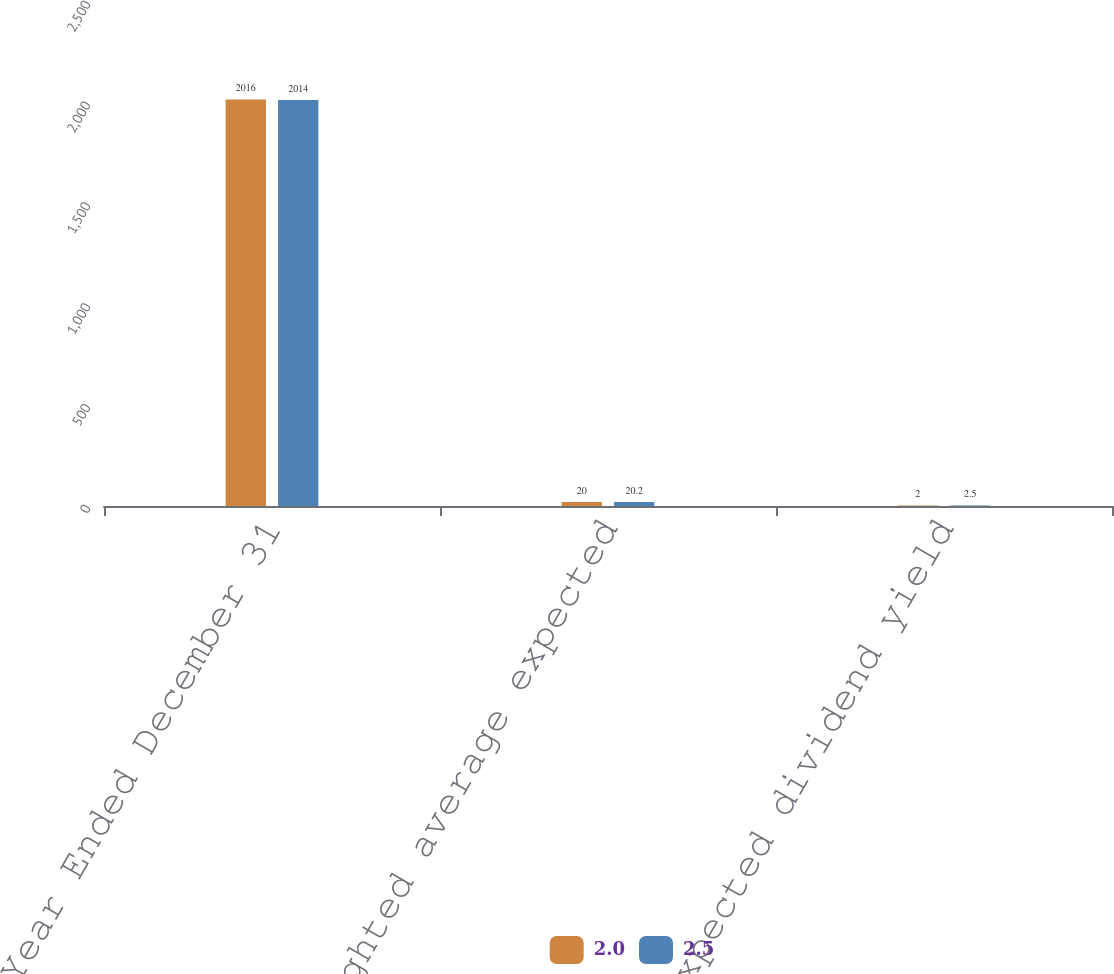Convert chart. <chart><loc_0><loc_0><loc_500><loc_500><stacked_bar_chart><ecel><fcel>Year Ended December 31<fcel>Weighted average expected<fcel>Expected dividend yield<nl><fcel>2<fcel>2016<fcel>20<fcel>2<nl><fcel>2.5<fcel>2014<fcel>20.2<fcel>2.5<nl></chart> 